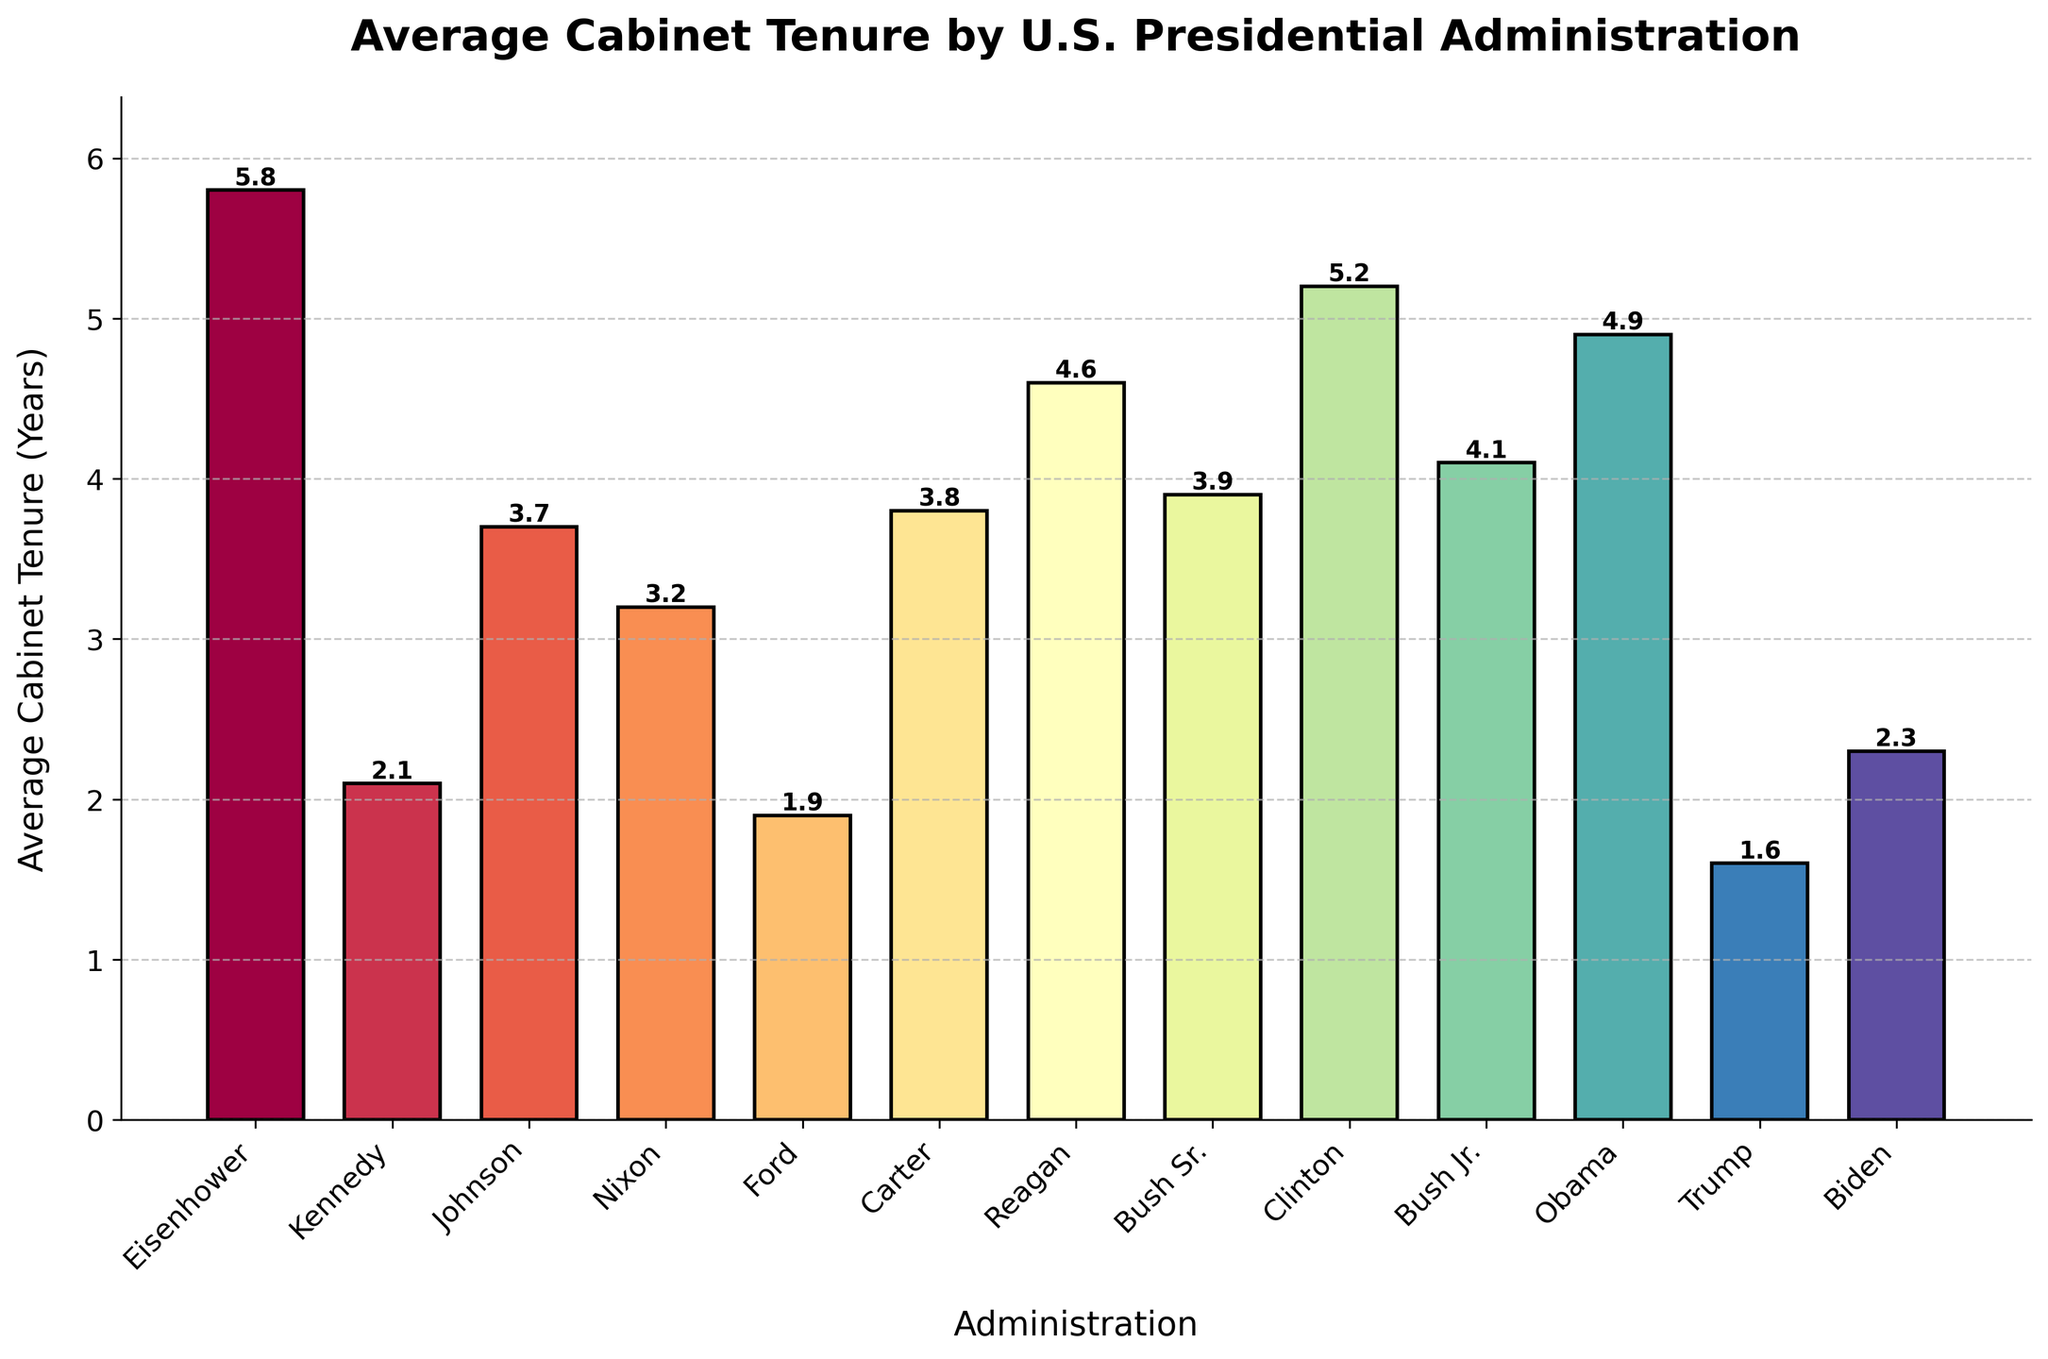Which administration had the longest average cabinet tenure? Look at the height of the bars and locate the tallest one. The tallest bar represents Eisenhower with an average cabinet tenure of 5.8 years.
Answer: Eisenhower How does Kennedy's average cabinet tenure compare to Trump's? Locate the bars for Kennedy and Trump and compare their heights. Kennedy's tenure is taller at 2.1 years, compared to Trump's 1.6 years.
Answer: Kennedy is longer than Trump What is the difference between the average cabinet tenures of Clinton and Obama? Look at the heights of the bars for Clinton and Obama. Clinton's average tenure is 5.2 years and Obama's is 4.9 years. Subtract the two values: 5.2 - 4.9 = 0.3 years.
Answer: 0.3 years What is the average cabinet tenure for the Bush family (Sr. and Jr.) combined? Look at the bars for Bush Sr. and Bush Jr., then sum their heights: 3.9 years + 4.1 years. Divide the sum by 2 to get the average: (3.9 + 4.1) / 2 = 4 years.
Answer: 4 years Which administration has a higher average cabinet tenure: Reagan or Carter? Compare the heights of the bars for Reagan and Carter. Reagan's bar is at 4.6 years, and Carter's bar is at 3.8 years.
Answer: Reagan What is the median average cabinet tenure among all administrations? List the tenures in ascending order: 1.6, 1.9, 2.1, 2.3, 3.2, 3.7, 3.8, 3.9, 4.1, 4.6, 4.9, 5.2, 5.8. The median (middle value in an ordered list) is the 7th value: 3.8 years.
Answer: 3.8 years Which administration's average cabinet tenure is closest to the overall average of all administrations? Calculate the overall average by summing all values and dividing by the number of administrations: (5.8+2.1+3.7+3.2+1.9+3.8+4.6+3.9+5.2+4.1+4.9+1.6+2.3)/13 ≈ 3.60 years. Compare each administration's tenure to see which is closest to 3.6. Johnson's tenure at 3.7 years is closest to 3.6 years.
Answer: Johnson What's the combined average cabinet tenure for the administrations with bars taller than 4 years? Identify administrations with bars taller than 4 years: Eisenhower (5.8), Clinton (5.2), Obama (4.9), Reagan (4.6), Bush Jr. (4.1). Sum these values and divide by the number of administrations: (5.8+5.2+4.9+4.6+4.1)/5 = 4.92 years.
Answer: 4.92 years 